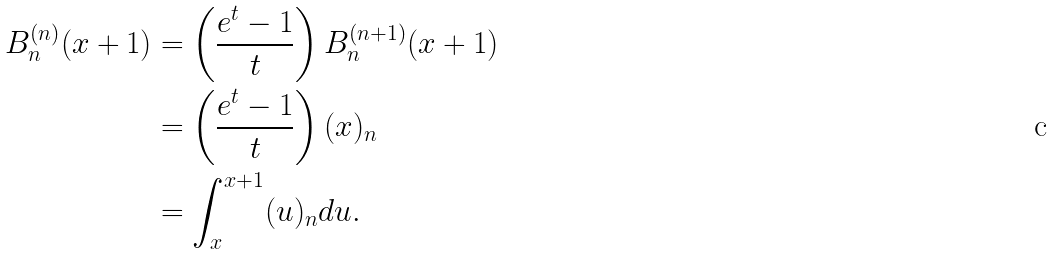Convert formula to latex. <formula><loc_0><loc_0><loc_500><loc_500>B _ { n } ^ { ( n ) } ( x + 1 ) & = \left ( \frac { e ^ { t } - 1 } { t } \right ) B _ { n } ^ { ( n + 1 ) } ( x + 1 ) \\ & = \left ( \frac { e ^ { t } - 1 } { t } \right ) ( x ) _ { n } \\ & = \int _ { x } ^ { x + 1 } ( u ) _ { n } d u .</formula> 